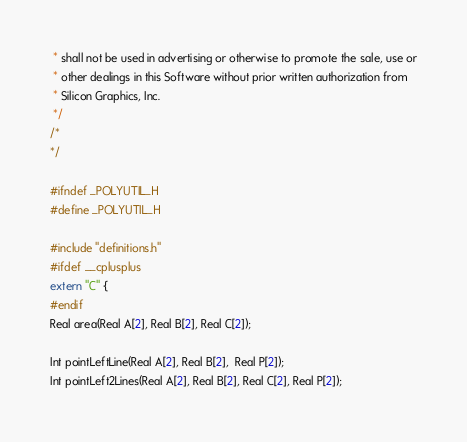Convert code to text. <code><loc_0><loc_0><loc_500><loc_500><_C_> * shall not be used in advertising or otherwise to promote the sale, use or
 * other dealings in this Software without prior written authorization from
 * Silicon Graphics, Inc.
 */
/*
*/

#ifndef _POLYUTIL_H
#define _POLYUTIL_H

#include "definitions.h"
#ifdef __cplusplus
extern "C" {
#endif
Real area(Real A[2], Real B[2], Real C[2]);

Int pointLeftLine(Real A[2], Real B[2],  Real P[2]);
Int pointLeft2Lines(Real A[2], Real B[2], Real C[2], Real P[2]);</code> 